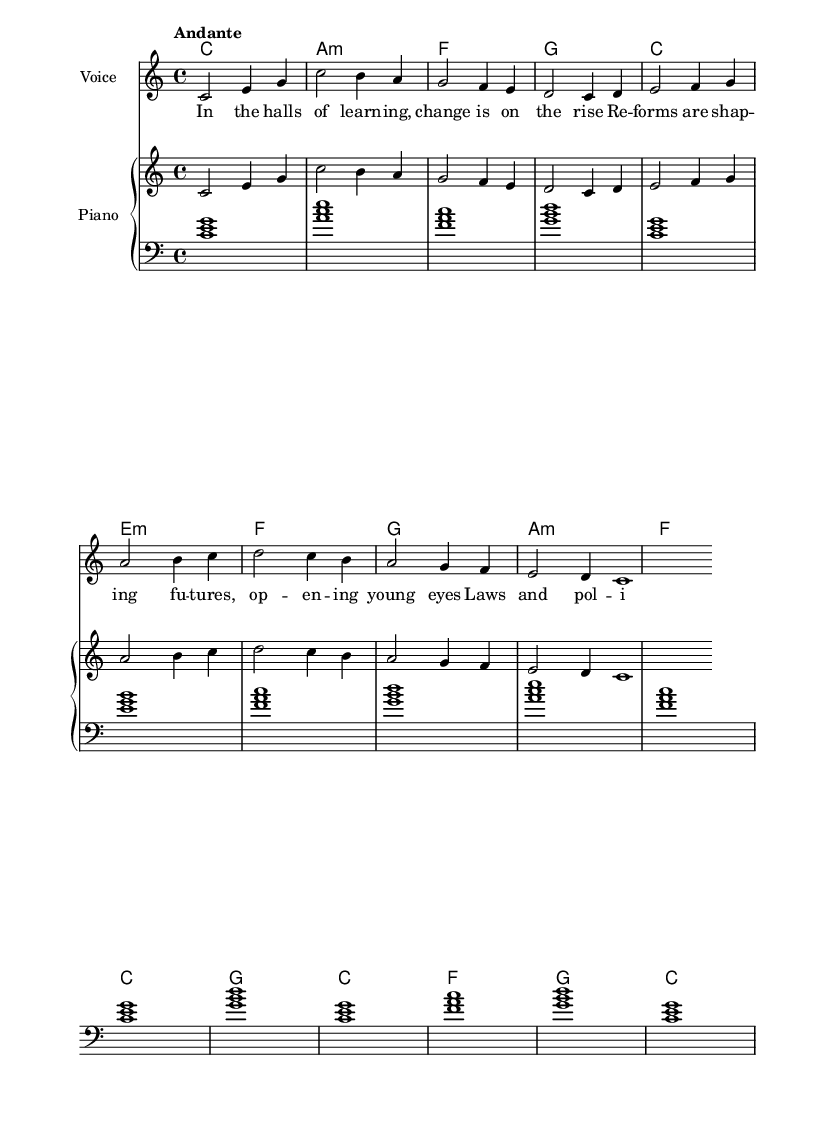What is the key signature of this music? The key signature is determined by the presence of sharps or flats at the beginning of the staff. In this case, there are no sharps or flats indicated, which corresponds to the key of C major.
Answer: C major What is the time signature of the piece? The time signature is indicated by the numbers at the beginning of the staff. In this case, 4/4 is shown, which means there are four beats in each measure and the quarter note receives one beat.
Answer: 4/4 What is the tempo marking for this piece? The tempo marking is usually indicated at the beginning of the piece, specifying how fast it should be played. Here, "Andante" is noted, which suggests a moderately slow tempo.
Answer: Andante How many measures are in the melody? By counting the individual measures visually on the staff, you can identify the number of measures present. In this piece, there are a total of eight measures in the melody section.
Answer: 8 What is the first word of the lyrics? The first word of the lyrics is located at the beginning of the lyric text provided below the melody. It clearly starts with "In".
Answer: In What is the overall shape of the melody? To determine the overall shape, one would observe the general rise and fall of the notes in the melody. After analyzing the contour, it is evident that the melody generally ascends at first and then descends.
Answer: Ascending then descending What is the harmonic structure of the piece? The harmonic structure can be evaluated by looking at the chords underneath the melody. The piece appears to follow a sequence of different chords with the chords indicated at the bottom, providing a clear harmonic progression.
Answer: C, A minor, F, G 